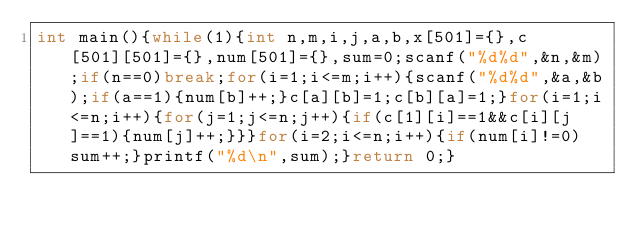<code> <loc_0><loc_0><loc_500><loc_500><_C_>int main(){while(1){int n,m,i,j,a,b,x[501]={},c[501][501]={},num[501]={},sum=0;scanf("%d%d",&n,&m);if(n==0)break;for(i=1;i<=m;i++){scanf("%d%d",&a,&b);if(a==1){num[b]++;}c[a][b]=1;c[b][a]=1;}for(i=1;i<=n;i++){for(j=1;j<=n;j++){if(c[1][i]==1&&c[i][j]==1){num[j]++;}}}for(i=2;i<=n;i++){if(num[i]!=0)sum++;}printf("%d\n",sum);}return 0;}</code> 